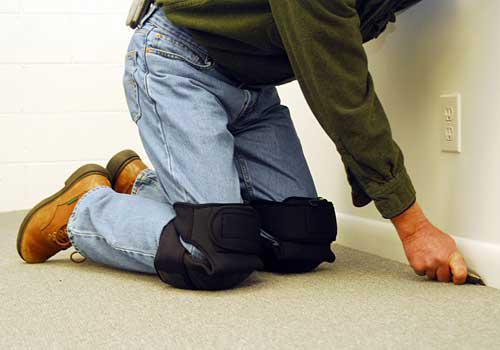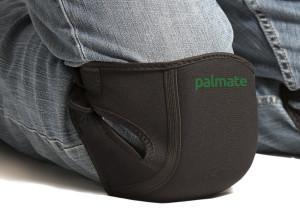The first image is the image on the left, the second image is the image on the right. Given the left and right images, does the statement "There are two pairs of unworn knee pads" hold true? Answer yes or no. No. The first image is the image on the left, the second image is the image on the right. For the images displayed, is the sentence "Each image shows a pair of unworn knee pads." factually correct? Answer yes or no. No. 